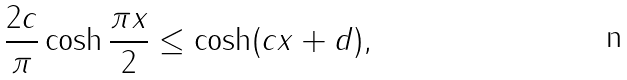<formula> <loc_0><loc_0><loc_500><loc_500>\frac { 2 c } { \pi } \cosh \frac { \pi x } { 2 } \leq \cosh ( c x + d ) ,</formula> 